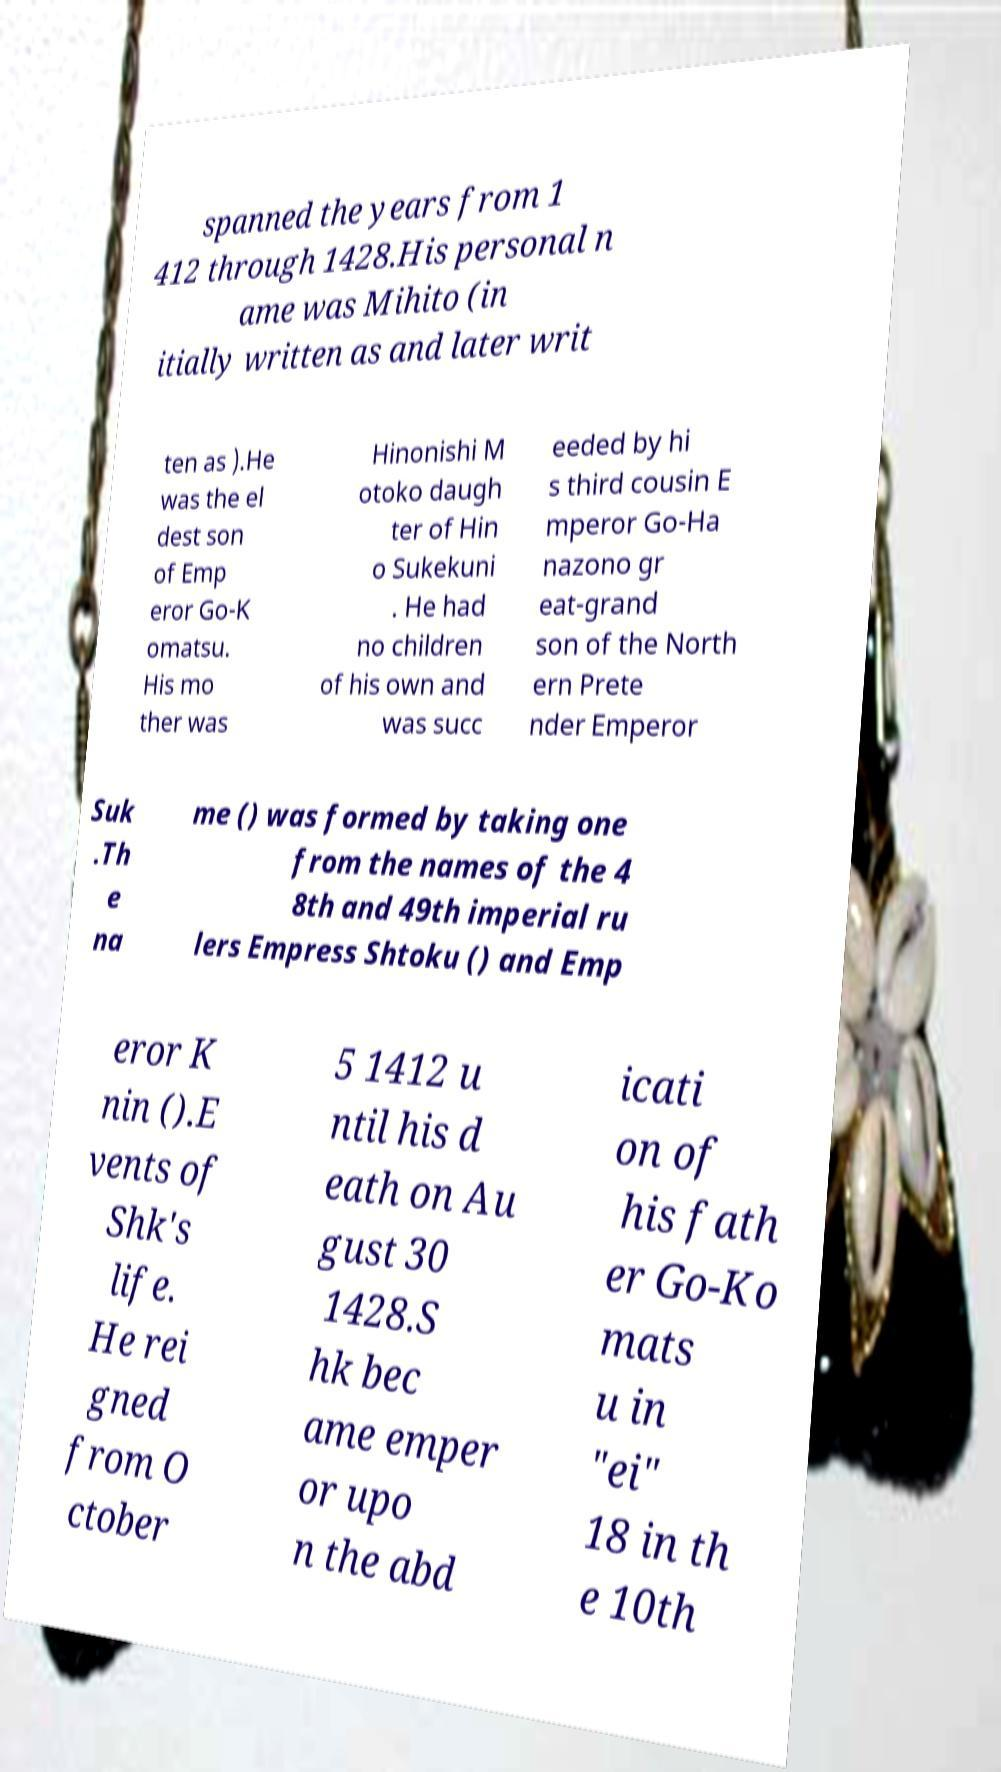Could you assist in decoding the text presented in this image and type it out clearly? spanned the years from 1 412 through 1428.His personal n ame was Mihito (in itially written as and later writ ten as ).He was the el dest son of Emp eror Go-K omatsu. His mo ther was Hinonishi M otoko daugh ter of Hin o Sukekuni . He had no children of his own and was succ eeded by hi s third cousin E mperor Go-Ha nazono gr eat-grand son of the North ern Prete nder Emperor Suk .Th e na me () was formed by taking one from the names of the 4 8th and 49th imperial ru lers Empress Shtoku () and Emp eror K nin ().E vents of Shk's life. He rei gned from O ctober 5 1412 u ntil his d eath on Au gust 30 1428.S hk bec ame emper or upo n the abd icati on of his fath er Go-Ko mats u in "ei" 18 in th e 10th 